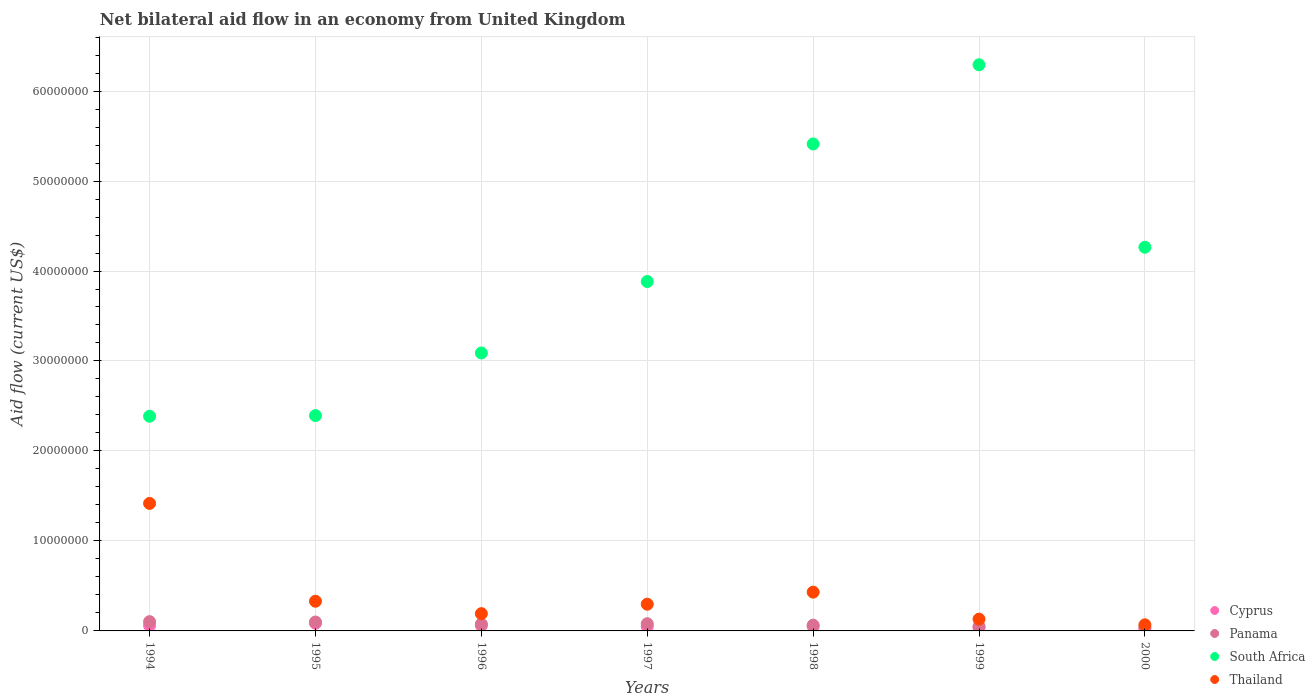How many different coloured dotlines are there?
Your response must be concise. 4. Is the number of dotlines equal to the number of legend labels?
Keep it short and to the point. Yes. Across all years, what is the maximum net bilateral aid flow in South Africa?
Ensure brevity in your answer.  6.29e+07. Across all years, what is the minimum net bilateral aid flow in South Africa?
Provide a succinct answer. 2.39e+07. In which year was the net bilateral aid flow in Cyprus maximum?
Provide a succinct answer. 1995. What is the total net bilateral aid flow in Panama in the graph?
Make the answer very short. 5.10e+06. What is the difference between the net bilateral aid flow in South Africa in 1995 and that in 1997?
Provide a short and direct response. -1.49e+07. What is the difference between the net bilateral aid flow in South Africa in 1994 and the net bilateral aid flow in Thailand in 1999?
Keep it short and to the point. 2.26e+07. What is the average net bilateral aid flow in Cyprus per year?
Your answer should be very brief. 5.19e+05. In how many years, is the net bilateral aid flow in Thailand greater than 54000000 US$?
Your answer should be very brief. 0. What is the ratio of the net bilateral aid flow in South Africa in 1998 to that in 2000?
Offer a terse response. 1.27. Is the net bilateral aid flow in Panama in 1996 less than that in 2000?
Offer a very short reply. No. What is the difference between the highest and the second highest net bilateral aid flow in Cyprus?
Keep it short and to the point. 2.60e+05. What is the difference between the highest and the lowest net bilateral aid flow in Panama?
Your answer should be very brief. 6.50e+05. Is the sum of the net bilateral aid flow in Cyprus in 1994 and 2000 greater than the maximum net bilateral aid flow in South Africa across all years?
Offer a terse response. No. Does the net bilateral aid flow in South Africa monotonically increase over the years?
Provide a short and direct response. No. Is the net bilateral aid flow in Cyprus strictly greater than the net bilateral aid flow in Panama over the years?
Your answer should be compact. No. Is the net bilateral aid flow in Panama strictly less than the net bilateral aid flow in Cyprus over the years?
Make the answer very short. No. Does the graph contain any zero values?
Ensure brevity in your answer.  No. Does the graph contain grids?
Ensure brevity in your answer.  Yes. Where does the legend appear in the graph?
Your response must be concise. Bottom right. How many legend labels are there?
Make the answer very short. 4. What is the title of the graph?
Offer a terse response. Net bilateral aid flow in an economy from United Kingdom. Does "Sub-Saharan Africa (developing only)" appear as one of the legend labels in the graph?
Your answer should be compact. No. What is the label or title of the X-axis?
Provide a succinct answer. Years. What is the Aid flow (current US$) of Cyprus in 1994?
Keep it short and to the point. 5.90e+05. What is the Aid flow (current US$) in Panama in 1994?
Your answer should be very brief. 1.03e+06. What is the Aid flow (current US$) in South Africa in 1994?
Offer a very short reply. 2.39e+07. What is the Aid flow (current US$) of Thailand in 1994?
Provide a succinct answer. 1.42e+07. What is the Aid flow (current US$) of Cyprus in 1995?
Provide a short and direct response. 8.50e+05. What is the Aid flow (current US$) in Panama in 1995?
Give a very brief answer. 9.90e+05. What is the Aid flow (current US$) in South Africa in 1995?
Ensure brevity in your answer.  2.39e+07. What is the Aid flow (current US$) of Thailand in 1995?
Provide a succinct answer. 3.30e+06. What is the Aid flow (current US$) in Cyprus in 1996?
Your answer should be very brief. 5.90e+05. What is the Aid flow (current US$) of Panama in 1996?
Offer a very short reply. 7.60e+05. What is the Aid flow (current US$) of South Africa in 1996?
Give a very brief answer. 3.09e+07. What is the Aid flow (current US$) of Thailand in 1996?
Your response must be concise. 1.92e+06. What is the Aid flow (current US$) in Cyprus in 1997?
Make the answer very short. 5.00e+05. What is the Aid flow (current US$) in Panama in 1997?
Give a very brief answer. 8.00e+05. What is the Aid flow (current US$) in South Africa in 1997?
Provide a succinct answer. 3.88e+07. What is the Aid flow (current US$) in Thailand in 1997?
Provide a short and direct response. 2.97e+06. What is the Aid flow (current US$) of Panama in 1998?
Keep it short and to the point. 6.40e+05. What is the Aid flow (current US$) in South Africa in 1998?
Your response must be concise. 5.41e+07. What is the Aid flow (current US$) in Thailand in 1998?
Give a very brief answer. 4.31e+06. What is the Aid flow (current US$) of Panama in 1999?
Provide a succinct answer. 5.00e+05. What is the Aid flow (current US$) of South Africa in 1999?
Provide a succinct answer. 6.29e+07. What is the Aid flow (current US$) of Thailand in 1999?
Make the answer very short. 1.31e+06. What is the Aid flow (current US$) in Cyprus in 2000?
Make the answer very short. 2.40e+05. What is the Aid flow (current US$) in South Africa in 2000?
Offer a terse response. 4.26e+07. What is the Aid flow (current US$) in Thailand in 2000?
Your answer should be compact. 6.80e+05. Across all years, what is the maximum Aid flow (current US$) in Cyprus?
Your answer should be compact. 8.50e+05. Across all years, what is the maximum Aid flow (current US$) in Panama?
Make the answer very short. 1.03e+06. Across all years, what is the maximum Aid flow (current US$) of South Africa?
Your answer should be very brief. 6.29e+07. Across all years, what is the maximum Aid flow (current US$) of Thailand?
Ensure brevity in your answer.  1.42e+07. Across all years, what is the minimum Aid flow (current US$) in Cyprus?
Provide a short and direct response. 2.40e+05. Across all years, what is the minimum Aid flow (current US$) in Panama?
Offer a terse response. 3.80e+05. Across all years, what is the minimum Aid flow (current US$) of South Africa?
Offer a very short reply. 2.39e+07. Across all years, what is the minimum Aid flow (current US$) of Thailand?
Your answer should be very brief. 6.80e+05. What is the total Aid flow (current US$) in Cyprus in the graph?
Keep it short and to the point. 3.63e+06. What is the total Aid flow (current US$) of Panama in the graph?
Your answer should be compact. 5.10e+06. What is the total Aid flow (current US$) of South Africa in the graph?
Ensure brevity in your answer.  2.77e+08. What is the total Aid flow (current US$) in Thailand in the graph?
Your answer should be compact. 2.87e+07. What is the difference between the Aid flow (current US$) of South Africa in 1994 and that in 1995?
Give a very brief answer. -7.00e+04. What is the difference between the Aid flow (current US$) in Thailand in 1994 and that in 1995?
Make the answer very short. 1.09e+07. What is the difference between the Aid flow (current US$) in Panama in 1994 and that in 1996?
Your response must be concise. 2.70e+05. What is the difference between the Aid flow (current US$) in South Africa in 1994 and that in 1996?
Offer a terse response. -7.03e+06. What is the difference between the Aid flow (current US$) of Thailand in 1994 and that in 1996?
Give a very brief answer. 1.22e+07. What is the difference between the Aid flow (current US$) in Cyprus in 1994 and that in 1997?
Provide a succinct answer. 9.00e+04. What is the difference between the Aid flow (current US$) in Panama in 1994 and that in 1997?
Give a very brief answer. 2.30e+05. What is the difference between the Aid flow (current US$) of South Africa in 1994 and that in 1997?
Offer a terse response. -1.50e+07. What is the difference between the Aid flow (current US$) of Thailand in 1994 and that in 1997?
Offer a terse response. 1.12e+07. What is the difference between the Aid flow (current US$) in Panama in 1994 and that in 1998?
Ensure brevity in your answer.  3.90e+05. What is the difference between the Aid flow (current US$) of South Africa in 1994 and that in 1998?
Make the answer very short. -3.03e+07. What is the difference between the Aid flow (current US$) in Thailand in 1994 and that in 1998?
Your answer should be very brief. 9.86e+06. What is the difference between the Aid flow (current US$) of Cyprus in 1994 and that in 1999?
Your response must be concise. 2.30e+05. What is the difference between the Aid flow (current US$) of Panama in 1994 and that in 1999?
Offer a terse response. 5.30e+05. What is the difference between the Aid flow (current US$) of South Africa in 1994 and that in 1999?
Ensure brevity in your answer.  -3.91e+07. What is the difference between the Aid flow (current US$) of Thailand in 1994 and that in 1999?
Your answer should be very brief. 1.29e+07. What is the difference between the Aid flow (current US$) in Cyprus in 1994 and that in 2000?
Make the answer very short. 3.50e+05. What is the difference between the Aid flow (current US$) of Panama in 1994 and that in 2000?
Your answer should be compact. 6.50e+05. What is the difference between the Aid flow (current US$) of South Africa in 1994 and that in 2000?
Provide a short and direct response. -1.88e+07. What is the difference between the Aid flow (current US$) in Thailand in 1994 and that in 2000?
Provide a short and direct response. 1.35e+07. What is the difference between the Aid flow (current US$) of Cyprus in 1995 and that in 1996?
Your answer should be very brief. 2.60e+05. What is the difference between the Aid flow (current US$) of Panama in 1995 and that in 1996?
Your answer should be very brief. 2.30e+05. What is the difference between the Aid flow (current US$) in South Africa in 1995 and that in 1996?
Your answer should be compact. -6.96e+06. What is the difference between the Aid flow (current US$) in Thailand in 1995 and that in 1996?
Offer a very short reply. 1.38e+06. What is the difference between the Aid flow (current US$) of Panama in 1995 and that in 1997?
Offer a terse response. 1.90e+05. What is the difference between the Aid flow (current US$) in South Africa in 1995 and that in 1997?
Provide a short and direct response. -1.49e+07. What is the difference between the Aid flow (current US$) of Thailand in 1995 and that in 1997?
Your answer should be compact. 3.30e+05. What is the difference between the Aid flow (current US$) of Cyprus in 1995 and that in 1998?
Your answer should be very brief. 3.50e+05. What is the difference between the Aid flow (current US$) of South Africa in 1995 and that in 1998?
Provide a short and direct response. -3.02e+07. What is the difference between the Aid flow (current US$) in Thailand in 1995 and that in 1998?
Offer a very short reply. -1.01e+06. What is the difference between the Aid flow (current US$) in South Africa in 1995 and that in 1999?
Give a very brief answer. -3.90e+07. What is the difference between the Aid flow (current US$) in Thailand in 1995 and that in 1999?
Offer a terse response. 1.99e+06. What is the difference between the Aid flow (current US$) of Cyprus in 1995 and that in 2000?
Provide a short and direct response. 6.10e+05. What is the difference between the Aid flow (current US$) in Panama in 1995 and that in 2000?
Keep it short and to the point. 6.10e+05. What is the difference between the Aid flow (current US$) in South Africa in 1995 and that in 2000?
Offer a very short reply. -1.87e+07. What is the difference between the Aid flow (current US$) of Thailand in 1995 and that in 2000?
Give a very brief answer. 2.62e+06. What is the difference between the Aid flow (current US$) in South Africa in 1996 and that in 1997?
Offer a terse response. -7.94e+06. What is the difference between the Aid flow (current US$) in Thailand in 1996 and that in 1997?
Your answer should be compact. -1.05e+06. What is the difference between the Aid flow (current US$) in Cyprus in 1996 and that in 1998?
Keep it short and to the point. 9.00e+04. What is the difference between the Aid flow (current US$) of Panama in 1996 and that in 1998?
Provide a short and direct response. 1.20e+05. What is the difference between the Aid flow (current US$) of South Africa in 1996 and that in 1998?
Make the answer very short. -2.32e+07. What is the difference between the Aid flow (current US$) of Thailand in 1996 and that in 1998?
Your answer should be compact. -2.39e+06. What is the difference between the Aid flow (current US$) in Cyprus in 1996 and that in 1999?
Provide a short and direct response. 2.30e+05. What is the difference between the Aid flow (current US$) of Panama in 1996 and that in 1999?
Provide a succinct answer. 2.60e+05. What is the difference between the Aid flow (current US$) in South Africa in 1996 and that in 1999?
Your response must be concise. -3.20e+07. What is the difference between the Aid flow (current US$) in Cyprus in 1996 and that in 2000?
Provide a short and direct response. 3.50e+05. What is the difference between the Aid flow (current US$) in South Africa in 1996 and that in 2000?
Your answer should be very brief. -1.18e+07. What is the difference between the Aid flow (current US$) of Thailand in 1996 and that in 2000?
Offer a very short reply. 1.24e+06. What is the difference between the Aid flow (current US$) in Panama in 1997 and that in 1998?
Your response must be concise. 1.60e+05. What is the difference between the Aid flow (current US$) in South Africa in 1997 and that in 1998?
Give a very brief answer. -1.53e+07. What is the difference between the Aid flow (current US$) in Thailand in 1997 and that in 1998?
Offer a terse response. -1.34e+06. What is the difference between the Aid flow (current US$) in Cyprus in 1997 and that in 1999?
Offer a very short reply. 1.40e+05. What is the difference between the Aid flow (current US$) in South Africa in 1997 and that in 1999?
Ensure brevity in your answer.  -2.41e+07. What is the difference between the Aid flow (current US$) of Thailand in 1997 and that in 1999?
Offer a very short reply. 1.66e+06. What is the difference between the Aid flow (current US$) in South Africa in 1997 and that in 2000?
Offer a very short reply. -3.81e+06. What is the difference between the Aid flow (current US$) in Thailand in 1997 and that in 2000?
Keep it short and to the point. 2.29e+06. What is the difference between the Aid flow (current US$) of Cyprus in 1998 and that in 1999?
Keep it short and to the point. 1.40e+05. What is the difference between the Aid flow (current US$) of South Africa in 1998 and that in 1999?
Keep it short and to the point. -8.80e+06. What is the difference between the Aid flow (current US$) in Thailand in 1998 and that in 1999?
Keep it short and to the point. 3.00e+06. What is the difference between the Aid flow (current US$) of Panama in 1998 and that in 2000?
Make the answer very short. 2.60e+05. What is the difference between the Aid flow (current US$) in South Africa in 1998 and that in 2000?
Give a very brief answer. 1.15e+07. What is the difference between the Aid flow (current US$) in Thailand in 1998 and that in 2000?
Your answer should be compact. 3.63e+06. What is the difference between the Aid flow (current US$) in Cyprus in 1999 and that in 2000?
Ensure brevity in your answer.  1.20e+05. What is the difference between the Aid flow (current US$) of South Africa in 1999 and that in 2000?
Give a very brief answer. 2.03e+07. What is the difference between the Aid flow (current US$) in Thailand in 1999 and that in 2000?
Provide a short and direct response. 6.30e+05. What is the difference between the Aid flow (current US$) of Cyprus in 1994 and the Aid flow (current US$) of Panama in 1995?
Offer a very short reply. -4.00e+05. What is the difference between the Aid flow (current US$) of Cyprus in 1994 and the Aid flow (current US$) of South Africa in 1995?
Provide a short and direct response. -2.33e+07. What is the difference between the Aid flow (current US$) of Cyprus in 1994 and the Aid flow (current US$) of Thailand in 1995?
Your answer should be compact. -2.71e+06. What is the difference between the Aid flow (current US$) of Panama in 1994 and the Aid flow (current US$) of South Africa in 1995?
Your answer should be very brief. -2.29e+07. What is the difference between the Aid flow (current US$) in Panama in 1994 and the Aid flow (current US$) in Thailand in 1995?
Offer a very short reply. -2.27e+06. What is the difference between the Aid flow (current US$) in South Africa in 1994 and the Aid flow (current US$) in Thailand in 1995?
Offer a terse response. 2.06e+07. What is the difference between the Aid flow (current US$) in Cyprus in 1994 and the Aid flow (current US$) in South Africa in 1996?
Your response must be concise. -3.03e+07. What is the difference between the Aid flow (current US$) in Cyprus in 1994 and the Aid flow (current US$) in Thailand in 1996?
Your answer should be very brief. -1.33e+06. What is the difference between the Aid flow (current US$) in Panama in 1994 and the Aid flow (current US$) in South Africa in 1996?
Provide a succinct answer. -2.99e+07. What is the difference between the Aid flow (current US$) of Panama in 1994 and the Aid flow (current US$) of Thailand in 1996?
Give a very brief answer. -8.90e+05. What is the difference between the Aid flow (current US$) in South Africa in 1994 and the Aid flow (current US$) in Thailand in 1996?
Keep it short and to the point. 2.19e+07. What is the difference between the Aid flow (current US$) in Cyprus in 1994 and the Aid flow (current US$) in Panama in 1997?
Make the answer very short. -2.10e+05. What is the difference between the Aid flow (current US$) of Cyprus in 1994 and the Aid flow (current US$) of South Africa in 1997?
Offer a terse response. -3.82e+07. What is the difference between the Aid flow (current US$) in Cyprus in 1994 and the Aid flow (current US$) in Thailand in 1997?
Your answer should be very brief. -2.38e+06. What is the difference between the Aid flow (current US$) in Panama in 1994 and the Aid flow (current US$) in South Africa in 1997?
Offer a terse response. -3.78e+07. What is the difference between the Aid flow (current US$) in Panama in 1994 and the Aid flow (current US$) in Thailand in 1997?
Keep it short and to the point. -1.94e+06. What is the difference between the Aid flow (current US$) of South Africa in 1994 and the Aid flow (current US$) of Thailand in 1997?
Ensure brevity in your answer.  2.09e+07. What is the difference between the Aid flow (current US$) in Cyprus in 1994 and the Aid flow (current US$) in South Africa in 1998?
Your response must be concise. -5.35e+07. What is the difference between the Aid flow (current US$) in Cyprus in 1994 and the Aid flow (current US$) in Thailand in 1998?
Make the answer very short. -3.72e+06. What is the difference between the Aid flow (current US$) in Panama in 1994 and the Aid flow (current US$) in South Africa in 1998?
Offer a very short reply. -5.31e+07. What is the difference between the Aid flow (current US$) of Panama in 1994 and the Aid flow (current US$) of Thailand in 1998?
Offer a very short reply. -3.28e+06. What is the difference between the Aid flow (current US$) of South Africa in 1994 and the Aid flow (current US$) of Thailand in 1998?
Ensure brevity in your answer.  1.96e+07. What is the difference between the Aid flow (current US$) of Cyprus in 1994 and the Aid flow (current US$) of Panama in 1999?
Your answer should be compact. 9.00e+04. What is the difference between the Aid flow (current US$) of Cyprus in 1994 and the Aid flow (current US$) of South Africa in 1999?
Provide a short and direct response. -6.23e+07. What is the difference between the Aid flow (current US$) of Cyprus in 1994 and the Aid flow (current US$) of Thailand in 1999?
Make the answer very short. -7.20e+05. What is the difference between the Aid flow (current US$) of Panama in 1994 and the Aid flow (current US$) of South Africa in 1999?
Ensure brevity in your answer.  -6.19e+07. What is the difference between the Aid flow (current US$) in Panama in 1994 and the Aid flow (current US$) in Thailand in 1999?
Provide a short and direct response. -2.80e+05. What is the difference between the Aid flow (current US$) of South Africa in 1994 and the Aid flow (current US$) of Thailand in 1999?
Keep it short and to the point. 2.26e+07. What is the difference between the Aid flow (current US$) of Cyprus in 1994 and the Aid flow (current US$) of South Africa in 2000?
Make the answer very short. -4.20e+07. What is the difference between the Aid flow (current US$) in Cyprus in 1994 and the Aid flow (current US$) in Thailand in 2000?
Your response must be concise. -9.00e+04. What is the difference between the Aid flow (current US$) in Panama in 1994 and the Aid flow (current US$) in South Africa in 2000?
Offer a very short reply. -4.16e+07. What is the difference between the Aid flow (current US$) in Panama in 1994 and the Aid flow (current US$) in Thailand in 2000?
Keep it short and to the point. 3.50e+05. What is the difference between the Aid flow (current US$) in South Africa in 1994 and the Aid flow (current US$) in Thailand in 2000?
Ensure brevity in your answer.  2.32e+07. What is the difference between the Aid flow (current US$) of Cyprus in 1995 and the Aid flow (current US$) of South Africa in 1996?
Make the answer very short. -3.00e+07. What is the difference between the Aid flow (current US$) of Cyprus in 1995 and the Aid flow (current US$) of Thailand in 1996?
Your response must be concise. -1.07e+06. What is the difference between the Aid flow (current US$) of Panama in 1995 and the Aid flow (current US$) of South Africa in 1996?
Offer a terse response. -2.99e+07. What is the difference between the Aid flow (current US$) of Panama in 1995 and the Aid flow (current US$) of Thailand in 1996?
Give a very brief answer. -9.30e+05. What is the difference between the Aid flow (current US$) in South Africa in 1995 and the Aid flow (current US$) in Thailand in 1996?
Ensure brevity in your answer.  2.20e+07. What is the difference between the Aid flow (current US$) of Cyprus in 1995 and the Aid flow (current US$) of Panama in 1997?
Make the answer very short. 5.00e+04. What is the difference between the Aid flow (current US$) in Cyprus in 1995 and the Aid flow (current US$) in South Africa in 1997?
Your answer should be compact. -3.80e+07. What is the difference between the Aid flow (current US$) in Cyprus in 1995 and the Aid flow (current US$) in Thailand in 1997?
Offer a terse response. -2.12e+06. What is the difference between the Aid flow (current US$) in Panama in 1995 and the Aid flow (current US$) in South Africa in 1997?
Offer a very short reply. -3.78e+07. What is the difference between the Aid flow (current US$) in Panama in 1995 and the Aid flow (current US$) in Thailand in 1997?
Keep it short and to the point. -1.98e+06. What is the difference between the Aid flow (current US$) of South Africa in 1995 and the Aid flow (current US$) of Thailand in 1997?
Your answer should be compact. 2.10e+07. What is the difference between the Aid flow (current US$) of Cyprus in 1995 and the Aid flow (current US$) of South Africa in 1998?
Make the answer very short. -5.33e+07. What is the difference between the Aid flow (current US$) in Cyprus in 1995 and the Aid flow (current US$) in Thailand in 1998?
Keep it short and to the point. -3.46e+06. What is the difference between the Aid flow (current US$) of Panama in 1995 and the Aid flow (current US$) of South Africa in 1998?
Provide a succinct answer. -5.31e+07. What is the difference between the Aid flow (current US$) in Panama in 1995 and the Aid flow (current US$) in Thailand in 1998?
Give a very brief answer. -3.32e+06. What is the difference between the Aid flow (current US$) in South Africa in 1995 and the Aid flow (current US$) in Thailand in 1998?
Provide a succinct answer. 1.96e+07. What is the difference between the Aid flow (current US$) in Cyprus in 1995 and the Aid flow (current US$) in Panama in 1999?
Your answer should be very brief. 3.50e+05. What is the difference between the Aid flow (current US$) in Cyprus in 1995 and the Aid flow (current US$) in South Africa in 1999?
Provide a short and direct response. -6.21e+07. What is the difference between the Aid flow (current US$) in Cyprus in 1995 and the Aid flow (current US$) in Thailand in 1999?
Keep it short and to the point. -4.60e+05. What is the difference between the Aid flow (current US$) of Panama in 1995 and the Aid flow (current US$) of South Africa in 1999?
Provide a succinct answer. -6.19e+07. What is the difference between the Aid flow (current US$) of Panama in 1995 and the Aid flow (current US$) of Thailand in 1999?
Make the answer very short. -3.20e+05. What is the difference between the Aid flow (current US$) of South Africa in 1995 and the Aid flow (current US$) of Thailand in 1999?
Your answer should be compact. 2.26e+07. What is the difference between the Aid flow (current US$) of Cyprus in 1995 and the Aid flow (current US$) of South Africa in 2000?
Make the answer very short. -4.18e+07. What is the difference between the Aid flow (current US$) of Panama in 1995 and the Aid flow (current US$) of South Africa in 2000?
Your answer should be very brief. -4.16e+07. What is the difference between the Aid flow (current US$) in Panama in 1995 and the Aid flow (current US$) in Thailand in 2000?
Your answer should be very brief. 3.10e+05. What is the difference between the Aid flow (current US$) of South Africa in 1995 and the Aid flow (current US$) of Thailand in 2000?
Your response must be concise. 2.32e+07. What is the difference between the Aid flow (current US$) of Cyprus in 1996 and the Aid flow (current US$) of Panama in 1997?
Provide a succinct answer. -2.10e+05. What is the difference between the Aid flow (current US$) of Cyprus in 1996 and the Aid flow (current US$) of South Africa in 1997?
Make the answer very short. -3.82e+07. What is the difference between the Aid flow (current US$) in Cyprus in 1996 and the Aid flow (current US$) in Thailand in 1997?
Your response must be concise. -2.38e+06. What is the difference between the Aid flow (current US$) in Panama in 1996 and the Aid flow (current US$) in South Africa in 1997?
Offer a terse response. -3.81e+07. What is the difference between the Aid flow (current US$) of Panama in 1996 and the Aid flow (current US$) of Thailand in 1997?
Your response must be concise. -2.21e+06. What is the difference between the Aid flow (current US$) of South Africa in 1996 and the Aid flow (current US$) of Thailand in 1997?
Your answer should be compact. 2.79e+07. What is the difference between the Aid flow (current US$) in Cyprus in 1996 and the Aid flow (current US$) in Panama in 1998?
Your answer should be compact. -5.00e+04. What is the difference between the Aid flow (current US$) in Cyprus in 1996 and the Aid flow (current US$) in South Africa in 1998?
Your answer should be compact. -5.35e+07. What is the difference between the Aid flow (current US$) in Cyprus in 1996 and the Aid flow (current US$) in Thailand in 1998?
Give a very brief answer. -3.72e+06. What is the difference between the Aid flow (current US$) of Panama in 1996 and the Aid flow (current US$) of South Africa in 1998?
Offer a terse response. -5.34e+07. What is the difference between the Aid flow (current US$) in Panama in 1996 and the Aid flow (current US$) in Thailand in 1998?
Make the answer very short. -3.55e+06. What is the difference between the Aid flow (current US$) of South Africa in 1996 and the Aid flow (current US$) of Thailand in 1998?
Your answer should be compact. 2.66e+07. What is the difference between the Aid flow (current US$) in Cyprus in 1996 and the Aid flow (current US$) in South Africa in 1999?
Provide a short and direct response. -6.23e+07. What is the difference between the Aid flow (current US$) in Cyprus in 1996 and the Aid flow (current US$) in Thailand in 1999?
Make the answer very short. -7.20e+05. What is the difference between the Aid flow (current US$) of Panama in 1996 and the Aid flow (current US$) of South Africa in 1999?
Offer a very short reply. -6.22e+07. What is the difference between the Aid flow (current US$) in Panama in 1996 and the Aid flow (current US$) in Thailand in 1999?
Your answer should be very brief. -5.50e+05. What is the difference between the Aid flow (current US$) of South Africa in 1996 and the Aid flow (current US$) of Thailand in 1999?
Your answer should be very brief. 2.96e+07. What is the difference between the Aid flow (current US$) of Cyprus in 1996 and the Aid flow (current US$) of South Africa in 2000?
Give a very brief answer. -4.20e+07. What is the difference between the Aid flow (current US$) in Panama in 1996 and the Aid flow (current US$) in South Africa in 2000?
Offer a terse response. -4.19e+07. What is the difference between the Aid flow (current US$) of South Africa in 1996 and the Aid flow (current US$) of Thailand in 2000?
Keep it short and to the point. 3.02e+07. What is the difference between the Aid flow (current US$) in Cyprus in 1997 and the Aid flow (current US$) in South Africa in 1998?
Provide a succinct answer. -5.36e+07. What is the difference between the Aid flow (current US$) of Cyprus in 1997 and the Aid flow (current US$) of Thailand in 1998?
Make the answer very short. -3.81e+06. What is the difference between the Aid flow (current US$) of Panama in 1997 and the Aid flow (current US$) of South Africa in 1998?
Give a very brief answer. -5.33e+07. What is the difference between the Aid flow (current US$) of Panama in 1997 and the Aid flow (current US$) of Thailand in 1998?
Keep it short and to the point. -3.51e+06. What is the difference between the Aid flow (current US$) of South Africa in 1997 and the Aid flow (current US$) of Thailand in 1998?
Your answer should be compact. 3.45e+07. What is the difference between the Aid flow (current US$) of Cyprus in 1997 and the Aid flow (current US$) of Panama in 1999?
Offer a very short reply. 0. What is the difference between the Aid flow (current US$) in Cyprus in 1997 and the Aid flow (current US$) in South Africa in 1999?
Make the answer very short. -6.24e+07. What is the difference between the Aid flow (current US$) in Cyprus in 1997 and the Aid flow (current US$) in Thailand in 1999?
Your answer should be compact. -8.10e+05. What is the difference between the Aid flow (current US$) of Panama in 1997 and the Aid flow (current US$) of South Africa in 1999?
Offer a very short reply. -6.21e+07. What is the difference between the Aid flow (current US$) of Panama in 1997 and the Aid flow (current US$) of Thailand in 1999?
Make the answer very short. -5.10e+05. What is the difference between the Aid flow (current US$) in South Africa in 1997 and the Aid flow (current US$) in Thailand in 1999?
Offer a very short reply. 3.75e+07. What is the difference between the Aid flow (current US$) of Cyprus in 1997 and the Aid flow (current US$) of South Africa in 2000?
Make the answer very short. -4.21e+07. What is the difference between the Aid flow (current US$) in Panama in 1997 and the Aid flow (current US$) in South Africa in 2000?
Offer a terse response. -4.18e+07. What is the difference between the Aid flow (current US$) in South Africa in 1997 and the Aid flow (current US$) in Thailand in 2000?
Your response must be concise. 3.82e+07. What is the difference between the Aid flow (current US$) in Cyprus in 1998 and the Aid flow (current US$) in South Africa in 1999?
Offer a very short reply. -6.24e+07. What is the difference between the Aid flow (current US$) of Cyprus in 1998 and the Aid flow (current US$) of Thailand in 1999?
Your response must be concise. -8.10e+05. What is the difference between the Aid flow (current US$) in Panama in 1998 and the Aid flow (current US$) in South Africa in 1999?
Provide a short and direct response. -6.23e+07. What is the difference between the Aid flow (current US$) of Panama in 1998 and the Aid flow (current US$) of Thailand in 1999?
Offer a very short reply. -6.70e+05. What is the difference between the Aid flow (current US$) of South Africa in 1998 and the Aid flow (current US$) of Thailand in 1999?
Your response must be concise. 5.28e+07. What is the difference between the Aid flow (current US$) of Cyprus in 1998 and the Aid flow (current US$) of South Africa in 2000?
Make the answer very short. -4.21e+07. What is the difference between the Aid flow (current US$) in Panama in 1998 and the Aid flow (current US$) in South Africa in 2000?
Keep it short and to the point. -4.20e+07. What is the difference between the Aid flow (current US$) in Panama in 1998 and the Aid flow (current US$) in Thailand in 2000?
Your response must be concise. -4.00e+04. What is the difference between the Aid flow (current US$) of South Africa in 1998 and the Aid flow (current US$) of Thailand in 2000?
Give a very brief answer. 5.34e+07. What is the difference between the Aid flow (current US$) of Cyprus in 1999 and the Aid flow (current US$) of Panama in 2000?
Ensure brevity in your answer.  -2.00e+04. What is the difference between the Aid flow (current US$) in Cyprus in 1999 and the Aid flow (current US$) in South Africa in 2000?
Your answer should be compact. -4.23e+07. What is the difference between the Aid flow (current US$) of Cyprus in 1999 and the Aid flow (current US$) of Thailand in 2000?
Your answer should be very brief. -3.20e+05. What is the difference between the Aid flow (current US$) of Panama in 1999 and the Aid flow (current US$) of South Africa in 2000?
Your answer should be compact. -4.21e+07. What is the difference between the Aid flow (current US$) in Panama in 1999 and the Aid flow (current US$) in Thailand in 2000?
Keep it short and to the point. -1.80e+05. What is the difference between the Aid flow (current US$) in South Africa in 1999 and the Aid flow (current US$) in Thailand in 2000?
Provide a succinct answer. 6.22e+07. What is the average Aid flow (current US$) of Cyprus per year?
Offer a terse response. 5.19e+05. What is the average Aid flow (current US$) of Panama per year?
Your answer should be compact. 7.29e+05. What is the average Aid flow (current US$) in South Africa per year?
Your answer should be compact. 3.96e+07. What is the average Aid flow (current US$) in Thailand per year?
Provide a succinct answer. 4.09e+06. In the year 1994, what is the difference between the Aid flow (current US$) of Cyprus and Aid flow (current US$) of Panama?
Provide a succinct answer. -4.40e+05. In the year 1994, what is the difference between the Aid flow (current US$) in Cyprus and Aid flow (current US$) in South Africa?
Offer a terse response. -2.33e+07. In the year 1994, what is the difference between the Aid flow (current US$) in Cyprus and Aid flow (current US$) in Thailand?
Give a very brief answer. -1.36e+07. In the year 1994, what is the difference between the Aid flow (current US$) in Panama and Aid flow (current US$) in South Africa?
Give a very brief answer. -2.28e+07. In the year 1994, what is the difference between the Aid flow (current US$) in Panama and Aid flow (current US$) in Thailand?
Provide a succinct answer. -1.31e+07. In the year 1994, what is the difference between the Aid flow (current US$) in South Africa and Aid flow (current US$) in Thailand?
Offer a very short reply. 9.69e+06. In the year 1995, what is the difference between the Aid flow (current US$) of Cyprus and Aid flow (current US$) of Panama?
Ensure brevity in your answer.  -1.40e+05. In the year 1995, what is the difference between the Aid flow (current US$) in Cyprus and Aid flow (current US$) in South Africa?
Make the answer very short. -2.31e+07. In the year 1995, what is the difference between the Aid flow (current US$) in Cyprus and Aid flow (current US$) in Thailand?
Your answer should be very brief. -2.45e+06. In the year 1995, what is the difference between the Aid flow (current US$) in Panama and Aid flow (current US$) in South Africa?
Provide a short and direct response. -2.29e+07. In the year 1995, what is the difference between the Aid flow (current US$) in Panama and Aid flow (current US$) in Thailand?
Ensure brevity in your answer.  -2.31e+06. In the year 1995, what is the difference between the Aid flow (current US$) of South Africa and Aid flow (current US$) of Thailand?
Your answer should be compact. 2.06e+07. In the year 1996, what is the difference between the Aid flow (current US$) in Cyprus and Aid flow (current US$) in Panama?
Offer a very short reply. -1.70e+05. In the year 1996, what is the difference between the Aid flow (current US$) of Cyprus and Aid flow (current US$) of South Africa?
Your answer should be compact. -3.03e+07. In the year 1996, what is the difference between the Aid flow (current US$) in Cyprus and Aid flow (current US$) in Thailand?
Give a very brief answer. -1.33e+06. In the year 1996, what is the difference between the Aid flow (current US$) in Panama and Aid flow (current US$) in South Africa?
Your answer should be compact. -3.01e+07. In the year 1996, what is the difference between the Aid flow (current US$) of Panama and Aid flow (current US$) of Thailand?
Make the answer very short. -1.16e+06. In the year 1996, what is the difference between the Aid flow (current US$) in South Africa and Aid flow (current US$) in Thailand?
Your answer should be compact. 2.90e+07. In the year 1997, what is the difference between the Aid flow (current US$) in Cyprus and Aid flow (current US$) in South Africa?
Ensure brevity in your answer.  -3.83e+07. In the year 1997, what is the difference between the Aid flow (current US$) in Cyprus and Aid flow (current US$) in Thailand?
Your answer should be compact. -2.47e+06. In the year 1997, what is the difference between the Aid flow (current US$) of Panama and Aid flow (current US$) of South Africa?
Provide a short and direct response. -3.80e+07. In the year 1997, what is the difference between the Aid flow (current US$) in Panama and Aid flow (current US$) in Thailand?
Make the answer very short. -2.17e+06. In the year 1997, what is the difference between the Aid flow (current US$) of South Africa and Aid flow (current US$) of Thailand?
Your answer should be very brief. 3.59e+07. In the year 1998, what is the difference between the Aid flow (current US$) in Cyprus and Aid flow (current US$) in South Africa?
Ensure brevity in your answer.  -5.36e+07. In the year 1998, what is the difference between the Aid flow (current US$) in Cyprus and Aid flow (current US$) in Thailand?
Ensure brevity in your answer.  -3.81e+06. In the year 1998, what is the difference between the Aid flow (current US$) of Panama and Aid flow (current US$) of South Africa?
Provide a short and direct response. -5.35e+07. In the year 1998, what is the difference between the Aid flow (current US$) of Panama and Aid flow (current US$) of Thailand?
Offer a very short reply. -3.67e+06. In the year 1998, what is the difference between the Aid flow (current US$) in South Africa and Aid flow (current US$) in Thailand?
Offer a very short reply. 4.98e+07. In the year 1999, what is the difference between the Aid flow (current US$) in Cyprus and Aid flow (current US$) in South Africa?
Make the answer very short. -6.26e+07. In the year 1999, what is the difference between the Aid flow (current US$) in Cyprus and Aid flow (current US$) in Thailand?
Offer a terse response. -9.50e+05. In the year 1999, what is the difference between the Aid flow (current US$) in Panama and Aid flow (current US$) in South Africa?
Give a very brief answer. -6.24e+07. In the year 1999, what is the difference between the Aid flow (current US$) of Panama and Aid flow (current US$) of Thailand?
Offer a terse response. -8.10e+05. In the year 1999, what is the difference between the Aid flow (current US$) in South Africa and Aid flow (current US$) in Thailand?
Offer a very short reply. 6.16e+07. In the year 2000, what is the difference between the Aid flow (current US$) in Cyprus and Aid flow (current US$) in Panama?
Your response must be concise. -1.40e+05. In the year 2000, what is the difference between the Aid flow (current US$) of Cyprus and Aid flow (current US$) of South Africa?
Your response must be concise. -4.24e+07. In the year 2000, what is the difference between the Aid flow (current US$) of Cyprus and Aid flow (current US$) of Thailand?
Provide a short and direct response. -4.40e+05. In the year 2000, what is the difference between the Aid flow (current US$) of Panama and Aid flow (current US$) of South Africa?
Give a very brief answer. -4.23e+07. In the year 2000, what is the difference between the Aid flow (current US$) of South Africa and Aid flow (current US$) of Thailand?
Your response must be concise. 4.20e+07. What is the ratio of the Aid flow (current US$) of Cyprus in 1994 to that in 1995?
Your response must be concise. 0.69. What is the ratio of the Aid flow (current US$) of Panama in 1994 to that in 1995?
Your response must be concise. 1.04. What is the ratio of the Aid flow (current US$) in South Africa in 1994 to that in 1995?
Your answer should be very brief. 1. What is the ratio of the Aid flow (current US$) of Thailand in 1994 to that in 1995?
Make the answer very short. 4.29. What is the ratio of the Aid flow (current US$) in Cyprus in 1994 to that in 1996?
Provide a succinct answer. 1. What is the ratio of the Aid flow (current US$) of Panama in 1994 to that in 1996?
Provide a succinct answer. 1.36. What is the ratio of the Aid flow (current US$) of South Africa in 1994 to that in 1996?
Provide a short and direct response. 0.77. What is the ratio of the Aid flow (current US$) in Thailand in 1994 to that in 1996?
Offer a very short reply. 7.38. What is the ratio of the Aid flow (current US$) of Cyprus in 1994 to that in 1997?
Keep it short and to the point. 1.18. What is the ratio of the Aid flow (current US$) in Panama in 1994 to that in 1997?
Give a very brief answer. 1.29. What is the ratio of the Aid flow (current US$) of South Africa in 1994 to that in 1997?
Your answer should be compact. 0.61. What is the ratio of the Aid flow (current US$) in Thailand in 1994 to that in 1997?
Give a very brief answer. 4.77. What is the ratio of the Aid flow (current US$) in Cyprus in 1994 to that in 1998?
Give a very brief answer. 1.18. What is the ratio of the Aid flow (current US$) in Panama in 1994 to that in 1998?
Offer a terse response. 1.61. What is the ratio of the Aid flow (current US$) of South Africa in 1994 to that in 1998?
Provide a short and direct response. 0.44. What is the ratio of the Aid flow (current US$) of Thailand in 1994 to that in 1998?
Offer a very short reply. 3.29. What is the ratio of the Aid flow (current US$) in Cyprus in 1994 to that in 1999?
Your answer should be compact. 1.64. What is the ratio of the Aid flow (current US$) in Panama in 1994 to that in 1999?
Your answer should be very brief. 2.06. What is the ratio of the Aid flow (current US$) of South Africa in 1994 to that in 1999?
Provide a succinct answer. 0.38. What is the ratio of the Aid flow (current US$) of Thailand in 1994 to that in 1999?
Make the answer very short. 10.82. What is the ratio of the Aid flow (current US$) of Cyprus in 1994 to that in 2000?
Your answer should be compact. 2.46. What is the ratio of the Aid flow (current US$) of Panama in 1994 to that in 2000?
Offer a terse response. 2.71. What is the ratio of the Aid flow (current US$) of South Africa in 1994 to that in 2000?
Keep it short and to the point. 0.56. What is the ratio of the Aid flow (current US$) of Thailand in 1994 to that in 2000?
Your answer should be compact. 20.84. What is the ratio of the Aid flow (current US$) of Cyprus in 1995 to that in 1996?
Your answer should be very brief. 1.44. What is the ratio of the Aid flow (current US$) of Panama in 1995 to that in 1996?
Offer a very short reply. 1.3. What is the ratio of the Aid flow (current US$) of South Africa in 1995 to that in 1996?
Provide a short and direct response. 0.77. What is the ratio of the Aid flow (current US$) of Thailand in 1995 to that in 1996?
Offer a very short reply. 1.72. What is the ratio of the Aid flow (current US$) of Panama in 1995 to that in 1997?
Your answer should be compact. 1.24. What is the ratio of the Aid flow (current US$) of South Africa in 1995 to that in 1997?
Provide a short and direct response. 0.62. What is the ratio of the Aid flow (current US$) in Panama in 1995 to that in 1998?
Offer a terse response. 1.55. What is the ratio of the Aid flow (current US$) of South Africa in 1995 to that in 1998?
Keep it short and to the point. 0.44. What is the ratio of the Aid flow (current US$) of Thailand in 1995 to that in 1998?
Your answer should be very brief. 0.77. What is the ratio of the Aid flow (current US$) of Cyprus in 1995 to that in 1999?
Your answer should be compact. 2.36. What is the ratio of the Aid flow (current US$) of Panama in 1995 to that in 1999?
Ensure brevity in your answer.  1.98. What is the ratio of the Aid flow (current US$) of South Africa in 1995 to that in 1999?
Provide a succinct answer. 0.38. What is the ratio of the Aid flow (current US$) of Thailand in 1995 to that in 1999?
Make the answer very short. 2.52. What is the ratio of the Aid flow (current US$) in Cyprus in 1995 to that in 2000?
Provide a succinct answer. 3.54. What is the ratio of the Aid flow (current US$) of Panama in 1995 to that in 2000?
Give a very brief answer. 2.61. What is the ratio of the Aid flow (current US$) in South Africa in 1995 to that in 2000?
Make the answer very short. 0.56. What is the ratio of the Aid flow (current US$) of Thailand in 1995 to that in 2000?
Your response must be concise. 4.85. What is the ratio of the Aid flow (current US$) in Cyprus in 1996 to that in 1997?
Your answer should be very brief. 1.18. What is the ratio of the Aid flow (current US$) in South Africa in 1996 to that in 1997?
Make the answer very short. 0.8. What is the ratio of the Aid flow (current US$) in Thailand in 1996 to that in 1997?
Give a very brief answer. 0.65. What is the ratio of the Aid flow (current US$) of Cyprus in 1996 to that in 1998?
Your answer should be compact. 1.18. What is the ratio of the Aid flow (current US$) in Panama in 1996 to that in 1998?
Your answer should be compact. 1.19. What is the ratio of the Aid flow (current US$) of South Africa in 1996 to that in 1998?
Provide a short and direct response. 0.57. What is the ratio of the Aid flow (current US$) of Thailand in 1996 to that in 1998?
Your answer should be very brief. 0.45. What is the ratio of the Aid flow (current US$) in Cyprus in 1996 to that in 1999?
Offer a very short reply. 1.64. What is the ratio of the Aid flow (current US$) in Panama in 1996 to that in 1999?
Your answer should be very brief. 1.52. What is the ratio of the Aid flow (current US$) in South Africa in 1996 to that in 1999?
Offer a very short reply. 0.49. What is the ratio of the Aid flow (current US$) of Thailand in 1996 to that in 1999?
Offer a terse response. 1.47. What is the ratio of the Aid flow (current US$) in Cyprus in 1996 to that in 2000?
Ensure brevity in your answer.  2.46. What is the ratio of the Aid flow (current US$) of South Africa in 1996 to that in 2000?
Give a very brief answer. 0.72. What is the ratio of the Aid flow (current US$) in Thailand in 1996 to that in 2000?
Make the answer very short. 2.82. What is the ratio of the Aid flow (current US$) in Panama in 1997 to that in 1998?
Your response must be concise. 1.25. What is the ratio of the Aid flow (current US$) in South Africa in 1997 to that in 1998?
Your answer should be compact. 0.72. What is the ratio of the Aid flow (current US$) of Thailand in 1997 to that in 1998?
Make the answer very short. 0.69. What is the ratio of the Aid flow (current US$) of Cyprus in 1997 to that in 1999?
Provide a short and direct response. 1.39. What is the ratio of the Aid flow (current US$) of Panama in 1997 to that in 1999?
Keep it short and to the point. 1.6. What is the ratio of the Aid flow (current US$) in South Africa in 1997 to that in 1999?
Give a very brief answer. 0.62. What is the ratio of the Aid flow (current US$) in Thailand in 1997 to that in 1999?
Make the answer very short. 2.27. What is the ratio of the Aid flow (current US$) in Cyprus in 1997 to that in 2000?
Your response must be concise. 2.08. What is the ratio of the Aid flow (current US$) of Panama in 1997 to that in 2000?
Your answer should be very brief. 2.11. What is the ratio of the Aid flow (current US$) in South Africa in 1997 to that in 2000?
Your answer should be very brief. 0.91. What is the ratio of the Aid flow (current US$) of Thailand in 1997 to that in 2000?
Keep it short and to the point. 4.37. What is the ratio of the Aid flow (current US$) of Cyprus in 1998 to that in 1999?
Give a very brief answer. 1.39. What is the ratio of the Aid flow (current US$) in Panama in 1998 to that in 1999?
Give a very brief answer. 1.28. What is the ratio of the Aid flow (current US$) in South Africa in 1998 to that in 1999?
Provide a succinct answer. 0.86. What is the ratio of the Aid flow (current US$) in Thailand in 1998 to that in 1999?
Offer a terse response. 3.29. What is the ratio of the Aid flow (current US$) of Cyprus in 1998 to that in 2000?
Make the answer very short. 2.08. What is the ratio of the Aid flow (current US$) in Panama in 1998 to that in 2000?
Your response must be concise. 1.68. What is the ratio of the Aid flow (current US$) in South Africa in 1998 to that in 2000?
Your response must be concise. 1.27. What is the ratio of the Aid flow (current US$) in Thailand in 1998 to that in 2000?
Offer a terse response. 6.34. What is the ratio of the Aid flow (current US$) in Panama in 1999 to that in 2000?
Offer a very short reply. 1.32. What is the ratio of the Aid flow (current US$) in South Africa in 1999 to that in 2000?
Make the answer very short. 1.48. What is the ratio of the Aid flow (current US$) of Thailand in 1999 to that in 2000?
Offer a very short reply. 1.93. What is the difference between the highest and the second highest Aid flow (current US$) of Panama?
Your response must be concise. 4.00e+04. What is the difference between the highest and the second highest Aid flow (current US$) in South Africa?
Offer a very short reply. 8.80e+06. What is the difference between the highest and the second highest Aid flow (current US$) in Thailand?
Provide a short and direct response. 9.86e+06. What is the difference between the highest and the lowest Aid flow (current US$) of Panama?
Offer a very short reply. 6.50e+05. What is the difference between the highest and the lowest Aid flow (current US$) in South Africa?
Provide a succinct answer. 3.91e+07. What is the difference between the highest and the lowest Aid flow (current US$) in Thailand?
Keep it short and to the point. 1.35e+07. 